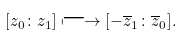Convert formula to latex. <formula><loc_0><loc_0><loc_500><loc_500>[ z _ { 0 } \colon z _ { 1 } ] \longmapsto [ - \overline { z } _ { 1 } \colon \overline { z } _ { 0 } ] .</formula> 